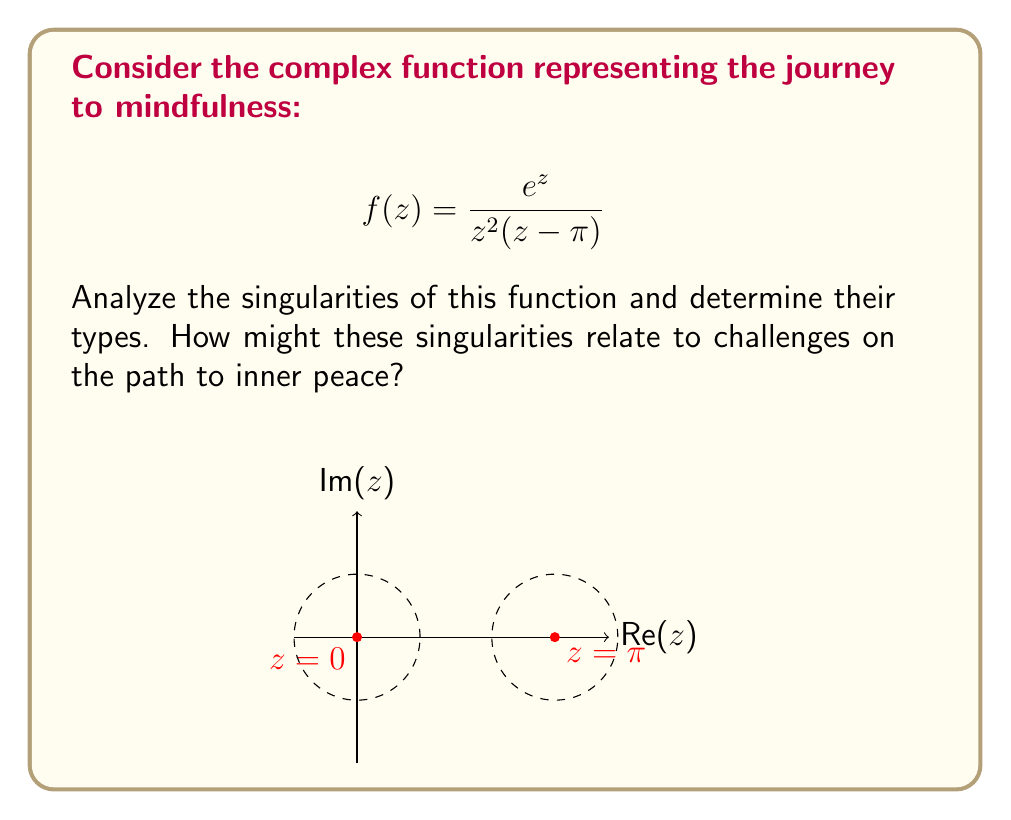Can you solve this math problem? To analyze the singularities of $f(z) = \frac{e^z}{z^2(z-\pi)}$, we follow these steps:

1) Identify the points where $f(z)$ is not analytic:
   - $z = 0$ (double zero in denominator)
   - $z = \pi$ (simple zero in denominator)

2) Analyze $z = 0$:
   - Let $g(z) = \frac{e^z}{z^2}$
   - $\lim_{z \to 0} zg(z) = \lim_{z \to 0} \frac{e^z}{z} = \lim_{z \to 0} \frac{e^z}{1} = 1 \neq 0$
   - $\lim_{z \to 0} z^2g(z) = \lim_{z \to 0} e^z = 1$
   This is a pole of order 2.

3) Analyze $z = \pi$:
   - Let $h(z) = \frac{e^z}{z^2(z-\pi)}$
   - $\lim_{z \to \pi} (z-\pi)h(z) = \lim_{z \to \pi} \frac{e^z}{z^2} = \frac{e^\pi}{\pi^2} \neq 0$
   This is a simple pole.

4) The function $e^z$ is entire, so it doesn't introduce any new singularities.

Interpretation for the journey to mindfulness:
- The double pole at $z = 0$ might represent the initial challenge of beginning the practice, requiring more effort to overcome.
- The simple pole at $z = \pi$ could symbolize a later obstacle on the path, perhaps easier to navigate with experience.
- The entire function $e^z$ in the numerator might represent the continuous growth and expansion of consciousness throughout the journey.
Answer: Double pole at $z = 0$, simple pole at $z = \pi$. 